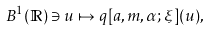<formula> <loc_0><loc_0><loc_500><loc_500>B ^ { 1 } ( \mathbb { R } ) \ni u \mapsto q [ a , m , \alpha ; \xi ] ( u ) ,</formula> 